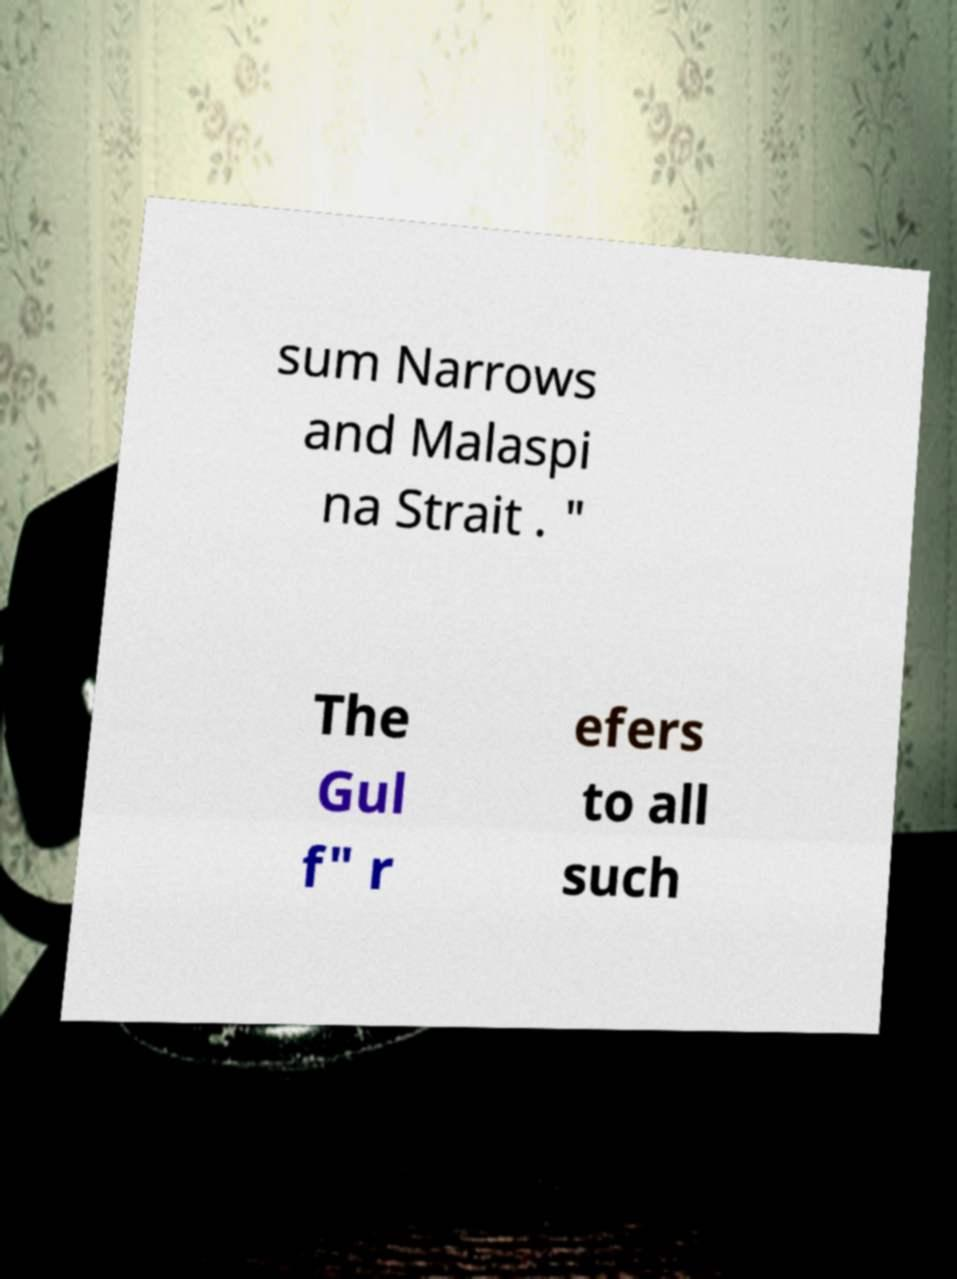Could you assist in decoding the text presented in this image and type it out clearly? sum Narrows and Malaspi na Strait . " The Gul f" r efers to all such 